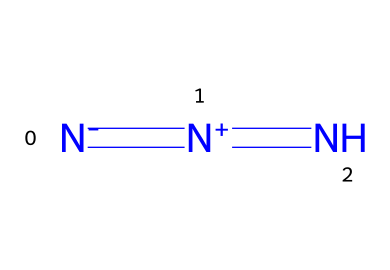What is the name of this chemical? The chemical represented by the SMILES N#N=N corresponds to hydrazoic acid, which is known for its azide group.
Answer: hydrazoic acid How many nitrogen atoms are in the structure? The SMILES string indicates the presence of three nitrogen atoms connected in a linear arrangement.
Answer: 3 What type of bonds are present in this chemical? The structure includes a triple bond between the first two nitrogen atoms, indicating a strong bond, and a single bond between the second and third nitrogen.
Answer: triple and single bonds What is the functional group present in hydrazoic acid? The presence of the -N3 (azide group) in the structure indicates the functional group that characterizes azides, which affects chemical reactivity.
Answer: azide group Why is hydrazoic acid used in prop smoke machines? The high energy release during the breakdown of hydrazoic acid produces a significant amount of gas, which contributes to the smoke effect in prop machines.
Answer: gas production What is the oxidation state of nitrogen in hydrazoic acid? The nitrogen atoms in hydrazoic acid have varying oxidation states, but the terminal nitrogen typically has an oxidation state of -1, while the others have different states depending on their connectivity in the structure.
Answer: -1 What type of chemical reaction can hydrazoic acid undergo? Hydrazoic acid can decompose through a reaction to produce nitrogen gas and other products, showcasing its instability at higher temperatures or under certain conditions.
Answer: decomposition 